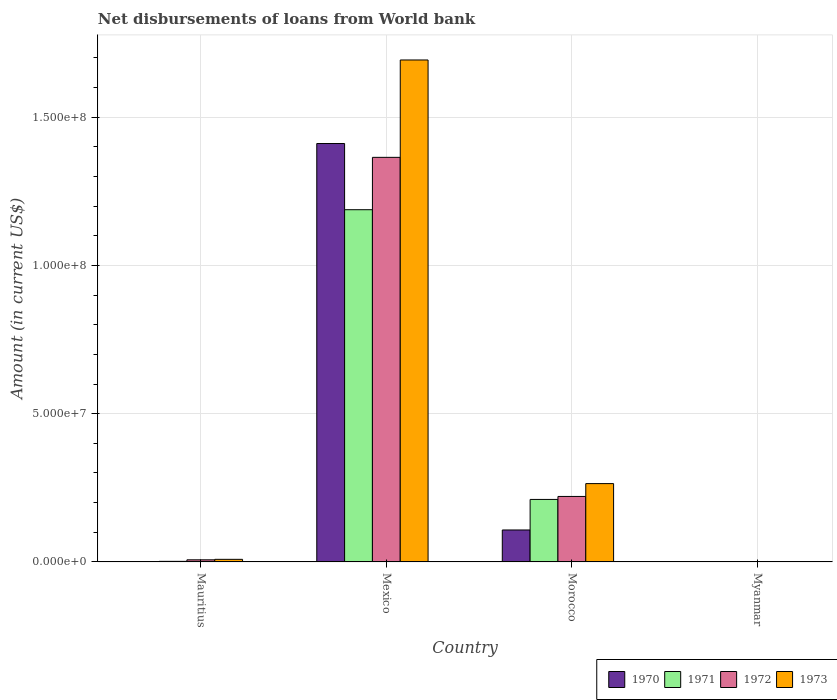How many different coloured bars are there?
Your answer should be very brief. 4. Are the number of bars on each tick of the X-axis equal?
Provide a succinct answer. No. How many bars are there on the 3rd tick from the left?
Your response must be concise. 4. What is the label of the 4th group of bars from the left?
Provide a short and direct response. Myanmar. What is the amount of loan disbursed from World Bank in 1973 in Myanmar?
Keep it short and to the point. 0. Across all countries, what is the maximum amount of loan disbursed from World Bank in 1971?
Ensure brevity in your answer.  1.19e+08. In which country was the amount of loan disbursed from World Bank in 1973 maximum?
Offer a terse response. Mexico. What is the total amount of loan disbursed from World Bank in 1972 in the graph?
Offer a very short reply. 1.59e+08. What is the difference between the amount of loan disbursed from World Bank in 1972 in Mauritius and that in Morocco?
Offer a terse response. -2.14e+07. What is the difference between the amount of loan disbursed from World Bank in 1973 in Myanmar and the amount of loan disbursed from World Bank in 1972 in Mauritius?
Your response must be concise. -7.17e+05. What is the average amount of loan disbursed from World Bank in 1973 per country?
Offer a very short reply. 4.91e+07. What is the difference between the amount of loan disbursed from World Bank of/in 1973 and amount of loan disbursed from World Bank of/in 1970 in Mexico?
Give a very brief answer. 2.82e+07. What is the ratio of the amount of loan disbursed from World Bank in 1972 in Mexico to that in Morocco?
Offer a very short reply. 6.18. What is the difference between the highest and the second highest amount of loan disbursed from World Bank in 1973?
Ensure brevity in your answer.  1.43e+08. What is the difference between the highest and the lowest amount of loan disbursed from World Bank in 1970?
Make the answer very short. 1.41e+08. In how many countries, is the amount of loan disbursed from World Bank in 1970 greater than the average amount of loan disbursed from World Bank in 1970 taken over all countries?
Your response must be concise. 1. Is the sum of the amount of loan disbursed from World Bank in 1972 in Mexico and Morocco greater than the maximum amount of loan disbursed from World Bank in 1973 across all countries?
Make the answer very short. No. Is it the case that in every country, the sum of the amount of loan disbursed from World Bank in 1973 and amount of loan disbursed from World Bank in 1971 is greater than the amount of loan disbursed from World Bank in 1970?
Your answer should be very brief. No. How many bars are there?
Your response must be concise. 11. How many countries are there in the graph?
Make the answer very short. 4. Does the graph contain any zero values?
Your response must be concise. Yes. How are the legend labels stacked?
Make the answer very short. Horizontal. What is the title of the graph?
Provide a short and direct response. Net disbursements of loans from World bank. Does "1978" appear as one of the legend labels in the graph?
Keep it short and to the point. No. What is the label or title of the X-axis?
Ensure brevity in your answer.  Country. What is the Amount (in current US$) of 1970 in Mauritius?
Provide a short and direct response. 0. What is the Amount (in current US$) of 1971 in Mauritius?
Keep it short and to the point. 1.99e+05. What is the Amount (in current US$) in 1972 in Mauritius?
Provide a short and direct response. 7.17e+05. What is the Amount (in current US$) of 1973 in Mauritius?
Provide a succinct answer. 8.79e+05. What is the Amount (in current US$) in 1970 in Mexico?
Your answer should be compact. 1.41e+08. What is the Amount (in current US$) of 1971 in Mexico?
Ensure brevity in your answer.  1.19e+08. What is the Amount (in current US$) of 1972 in Mexico?
Offer a very short reply. 1.36e+08. What is the Amount (in current US$) in 1973 in Mexico?
Provide a succinct answer. 1.69e+08. What is the Amount (in current US$) of 1970 in Morocco?
Your response must be concise. 1.08e+07. What is the Amount (in current US$) of 1971 in Morocco?
Provide a succinct answer. 2.11e+07. What is the Amount (in current US$) in 1972 in Morocco?
Give a very brief answer. 2.21e+07. What is the Amount (in current US$) in 1973 in Morocco?
Keep it short and to the point. 2.64e+07. What is the Amount (in current US$) in 1970 in Myanmar?
Your response must be concise. 0. What is the Amount (in current US$) in 1971 in Myanmar?
Your response must be concise. 0. Across all countries, what is the maximum Amount (in current US$) in 1970?
Offer a terse response. 1.41e+08. Across all countries, what is the maximum Amount (in current US$) of 1971?
Ensure brevity in your answer.  1.19e+08. Across all countries, what is the maximum Amount (in current US$) in 1972?
Offer a terse response. 1.36e+08. Across all countries, what is the maximum Amount (in current US$) in 1973?
Your response must be concise. 1.69e+08. What is the total Amount (in current US$) of 1970 in the graph?
Your answer should be very brief. 1.52e+08. What is the total Amount (in current US$) in 1971 in the graph?
Your answer should be very brief. 1.40e+08. What is the total Amount (in current US$) in 1972 in the graph?
Make the answer very short. 1.59e+08. What is the total Amount (in current US$) in 1973 in the graph?
Offer a very short reply. 1.97e+08. What is the difference between the Amount (in current US$) of 1971 in Mauritius and that in Mexico?
Offer a very short reply. -1.19e+08. What is the difference between the Amount (in current US$) of 1972 in Mauritius and that in Mexico?
Provide a succinct answer. -1.36e+08. What is the difference between the Amount (in current US$) in 1973 in Mauritius and that in Mexico?
Your answer should be very brief. -1.68e+08. What is the difference between the Amount (in current US$) in 1971 in Mauritius and that in Morocco?
Your response must be concise. -2.09e+07. What is the difference between the Amount (in current US$) in 1972 in Mauritius and that in Morocco?
Make the answer very short. -2.14e+07. What is the difference between the Amount (in current US$) in 1973 in Mauritius and that in Morocco?
Offer a very short reply. -2.55e+07. What is the difference between the Amount (in current US$) of 1970 in Mexico and that in Morocco?
Give a very brief answer. 1.30e+08. What is the difference between the Amount (in current US$) of 1971 in Mexico and that in Morocco?
Ensure brevity in your answer.  9.77e+07. What is the difference between the Amount (in current US$) in 1972 in Mexico and that in Morocco?
Ensure brevity in your answer.  1.14e+08. What is the difference between the Amount (in current US$) in 1973 in Mexico and that in Morocco?
Offer a terse response. 1.43e+08. What is the difference between the Amount (in current US$) of 1971 in Mauritius and the Amount (in current US$) of 1972 in Mexico?
Your answer should be very brief. -1.36e+08. What is the difference between the Amount (in current US$) of 1971 in Mauritius and the Amount (in current US$) of 1973 in Mexico?
Keep it short and to the point. -1.69e+08. What is the difference between the Amount (in current US$) of 1972 in Mauritius and the Amount (in current US$) of 1973 in Mexico?
Your response must be concise. -1.69e+08. What is the difference between the Amount (in current US$) in 1971 in Mauritius and the Amount (in current US$) in 1972 in Morocco?
Keep it short and to the point. -2.19e+07. What is the difference between the Amount (in current US$) of 1971 in Mauritius and the Amount (in current US$) of 1973 in Morocco?
Make the answer very short. -2.62e+07. What is the difference between the Amount (in current US$) in 1972 in Mauritius and the Amount (in current US$) in 1973 in Morocco?
Provide a succinct answer. -2.57e+07. What is the difference between the Amount (in current US$) of 1970 in Mexico and the Amount (in current US$) of 1971 in Morocco?
Provide a short and direct response. 1.20e+08. What is the difference between the Amount (in current US$) in 1970 in Mexico and the Amount (in current US$) in 1972 in Morocco?
Your answer should be compact. 1.19e+08. What is the difference between the Amount (in current US$) in 1970 in Mexico and the Amount (in current US$) in 1973 in Morocco?
Provide a succinct answer. 1.15e+08. What is the difference between the Amount (in current US$) in 1971 in Mexico and the Amount (in current US$) in 1972 in Morocco?
Offer a terse response. 9.67e+07. What is the difference between the Amount (in current US$) of 1971 in Mexico and the Amount (in current US$) of 1973 in Morocco?
Your answer should be very brief. 9.24e+07. What is the difference between the Amount (in current US$) in 1972 in Mexico and the Amount (in current US$) in 1973 in Morocco?
Offer a very short reply. 1.10e+08. What is the average Amount (in current US$) in 1970 per country?
Your response must be concise. 3.80e+07. What is the average Amount (in current US$) of 1971 per country?
Your answer should be very brief. 3.50e+07. What is the average Amount (in current US$) of 1972 per country?
Ensure brevity in your answer.  3.98e+07. What is the average Amount (in current US$) of 1973 per country?
Your answer should be compact. 4.91e+07. What is the difference between the Amount (in current US$) in 1971 and Amount (in current US$) in 1972 in Mauritius?
Make the answer very short. -5.18e+05. What is the difference between the Amount (in current US$) of 1971 and Amount (in current US$) of 1973 in Mauritius?
Offer a very short reply. -6.80e+05. What is the difference between the Amount (in current US$) of 1972 and Amount (in current US$) of 1973 in Mauritius?
Provide a succinct answer. -1.62e+05. What is the difference between the Amount (in current US$) of 1970 and Amount (in current US$) of 1971 in Mexico?
Give a very brief answer. 2.23e+07. What is the difference between the Amount (in current US$) of 1970 and Amount (in current US$) of 1972 in Mexico?
Your answer should be very brief. 4.66e+06. What is the difference between the Amount (in current US$) of 1970 and Amount (in current US$) of 1973 in Mexico?
Keep it short and to the point. -2.82e+07. What is the difference between the Amount (in current US$) of 1971 and Amount (in current US$) of 1972 in Mexico?
Offer a terse response. -1.77e+07. What is the difference between the Amount (in current US$) of 1971 and Amount (in current US$) of 1973 in Mexico?
Keep it short and to the point. -5.05e+07. What is the difference between the Amount (in current US$) of 1972 and Amount (in current US$) of 1973 in Mexico?
Ensure brevity in your answer.  -3.28e+07. What is the difference between the Amount (in current US$) in 1970 and Amount (in current US$) in 1971 in Morocco?
Your answer should be very brief. -1.03e+07. What is the difference between the Amount (in current US$) of 1970 and Amount (in current US$) of 1972 in Morocco?
Provide a succinct answer. -1.13e+07. What is the difference between the Amount (in current US$) of 1970 and Amount (in current US$) of 1973 in Morocco?
Give a very brief answer. -1.56e+07. What is the difference between the Amount (in current US$) of 1971 and Amount (in current US$) of 1972 in Morocco?
Offer a very short reply. -1.01e+06. What is the difference between the Amount (in current US$) in 1971 and Amount (in current US$) in 1973 in Morocco?
Provide a short and direct response. -5.34e+06. What is the difference between the Amount (in current US$) in 1972 and Amount (in current US$) in 1973 in Morocco?
Make the answer very short. -4.33e+06. What is the ratio of the Amount (in current US$) in 1971 in Mauritius to that in Mexico?
Ensure brevity in your answer.  0. What is the ratio of the Amount (in current US$) in 1972 in Mauritius to that in Mexico?
Keep it short and to the point. 0.01. What is the ratio of the Amount (in current US$) in 1973 in Mauritius to that in Mexico?
Offer a very short reply. 0.01. What is the ratio of the Amount (in current US$) in 1971 in Mauritius to that in Morocco?
Your response must be concise. 0.01. What is the ratio of the Amount (in current US$) of 1972 in Mauritius to that in Morocco?
Offer a very short reply. 0.03. What is the ratio of the Amount (in current US$) in 1973 in Mauritius to that in Morocco?
Your answer should be compact. 0.03. What is the ratio of the Amount (in current US$) in 1970 in Mexico to that in Morocco?
Make the answer very short. 13.09. What is the ratio of the Amount (in current US$) in 1971 in Mexico to that in Morocco?
Offer a very short reply. 5.63. What is the ratio of the Amount (in current US$) in 1972 in Mexico to that in Morocco?
Your response must be concise. 6.18. What is the ratio of the Amount (in current US$) of 1973 in Mexico to that in Morocco?
Make the answer very short. 6.41. What is the difference between the highest and the second highest Amount (in current US$) of 1971?
Your answer should be very brief. 9.77e+07. What is the difference between the highest and the second highest Amount (in current US$) of 1972?
Keep it short and to the point. 1.14e+08. What is the difference between the highest and the second highest Amount (in current US$) of 1973?
Your response must be concise. 1.43e+08. What is the difference between the highest and the lowest Amount (in current US$) of 1970?
Your answer should be very brief. 1.41e+08. What is the difference between the highest and the lowest Amount (in current US$) in 1971?
Offer a terse response. 1.19e+08. What is the difference between the highest and the lowest Amount (in current US$) of 1972?
Give a very brief answer. 1.36e+08. What is the difference between the highest and the lowest Amount (in current US$) of 1973?
Provide a short and direct response. 1.69e+08. 